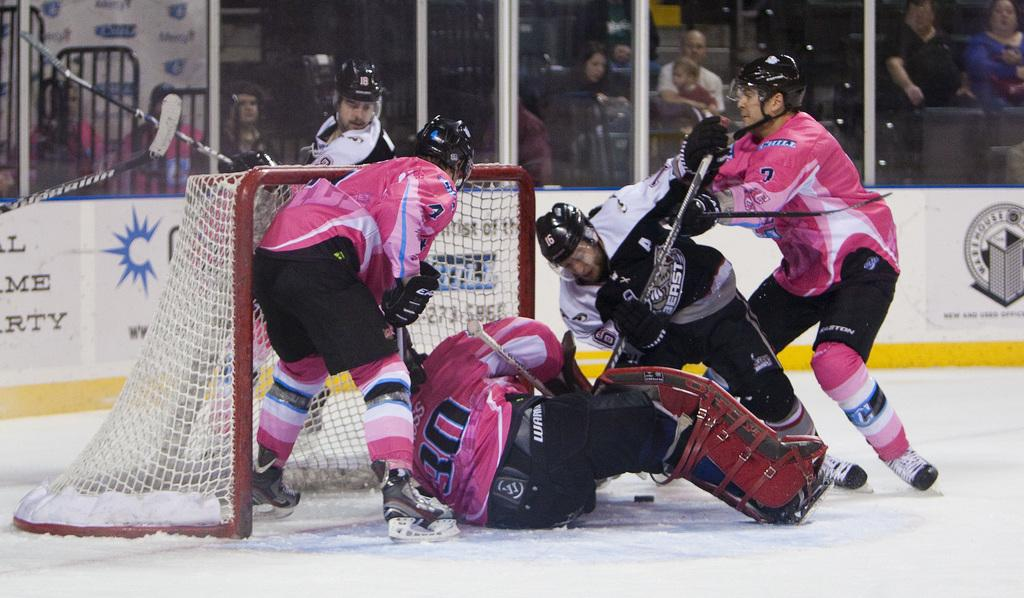<image>
Render a clear and concise summary of the photo. Hockey players are fighting for the puck and one has a 0 on his jersey. 